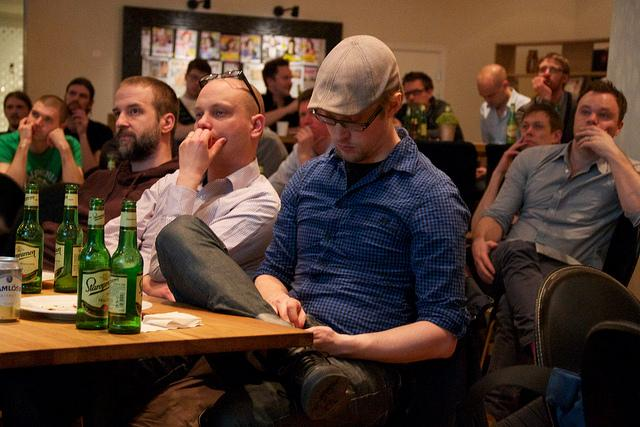How many people in this picture need to see an optometrist regularly?

Choices:
A) five
B) four
C) ten
D) thirteen four 